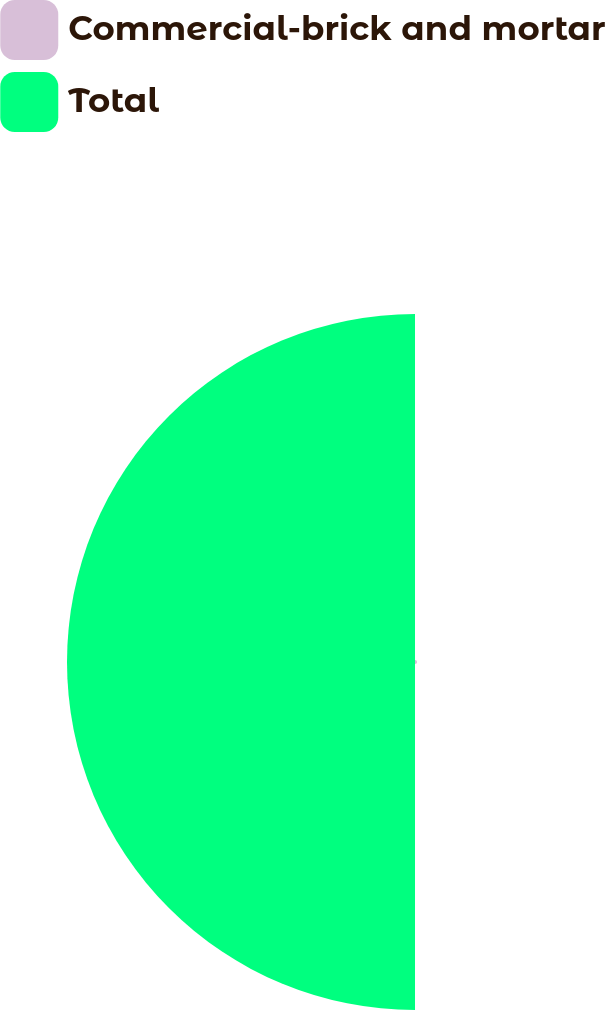Convert chart. <chart><loc_0><loc_0><loc_500><loc_500><pie_chart><fcel>Commercial-brick and mortar<fcel>Total<nl><fcel>0.59%<fcel>99.41%<nl></chart> 